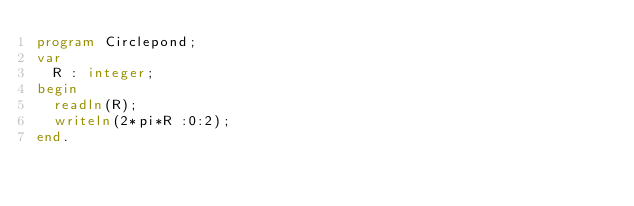Convert code to text. <code><loc_0><loc_0><loc_500><loc_500><_Pascal_>program Circlepond;
var
	R : integer;
begin
	readln(R);
	writeln(2*pi*R :0:2);
end.</code> 